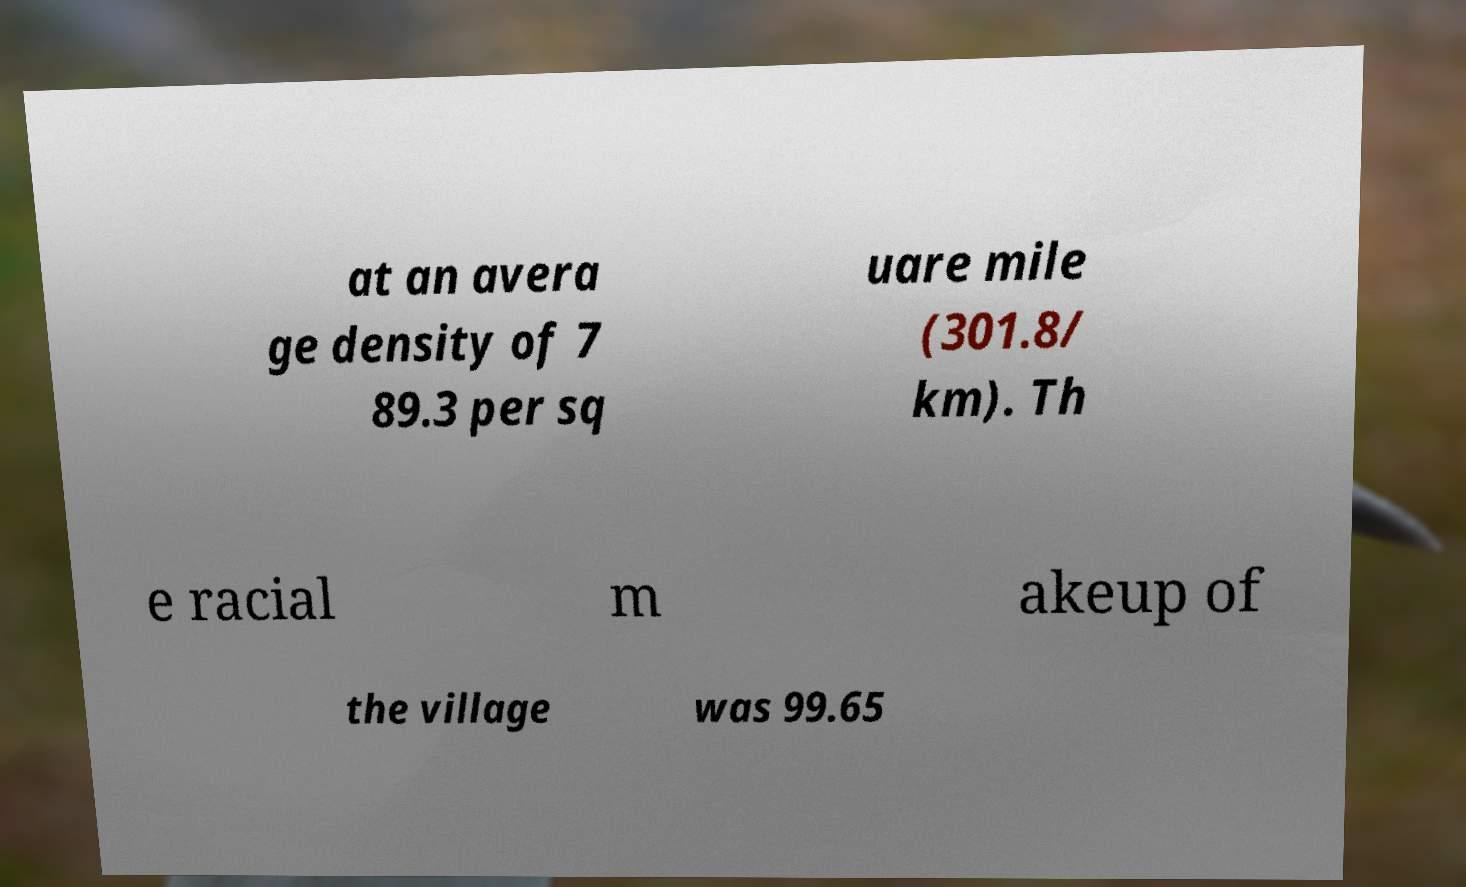For documentation purposes, I need the text within this image transcribed. Could you provide that? at an avera ge density of 7 89.3 per sq uare mile (301.8/ km). Th e racial m akeup of the village was 99.65 